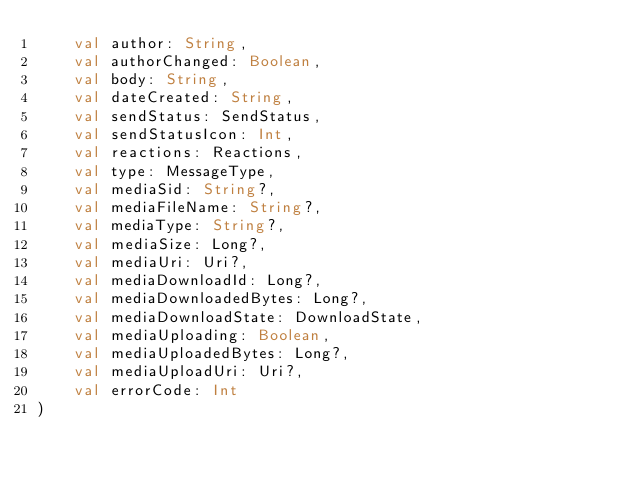<code> <loc_0><loc_0><loc_500><loc_500><_Kotlin_>    val author: String,
    val authorChanged: Boolean,
    val body: String,
    val dateCreated: String,
    val sendStatus: SendStatus,
    val sendStatusIcon: Int,
    val reactions: Reactions,
    val type: MessageType,
    val mediaSid: String?,
    val mediaFileName: String?,
    val mediaType: String?,
    val mediaSize: Long?,
    val mediaUri: Uri?,
    val mediaDownloadId: Long?,
    val mediaDownloadedBytes: Long?,
    val mediaDownloadState: DownloadState,
    val mediaUploading: Boolean,
    val mediaUploadedBytes: Long?,
    val mediaUploadUri: Uri?,
    val errorCode: Int
)
</code> 